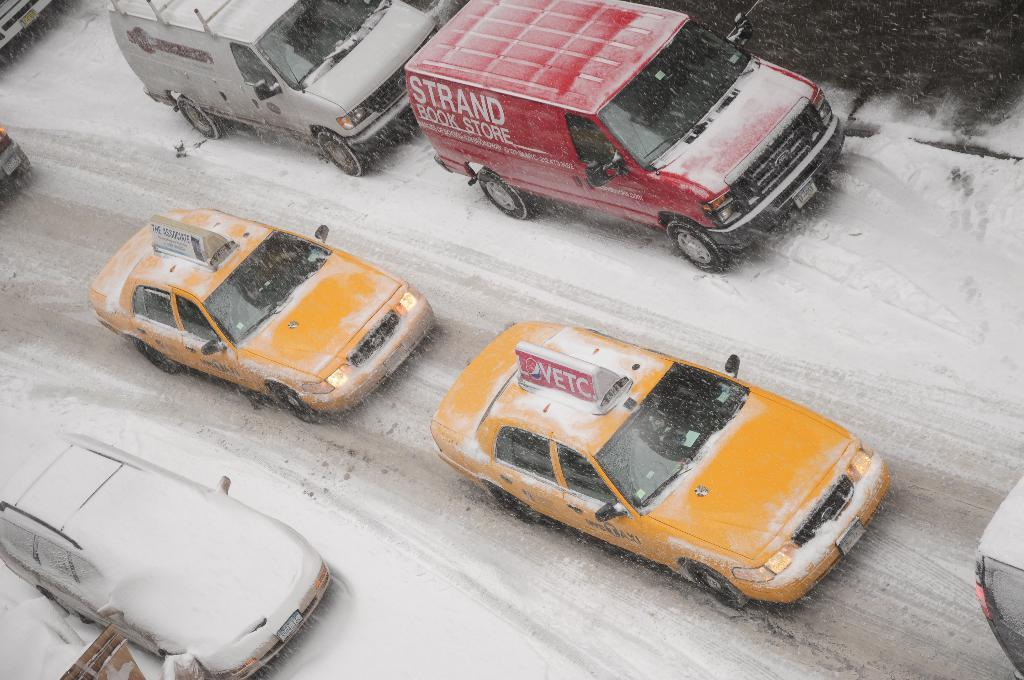<image>
Provide a brief description of the given image. Several vehicles are riding down a snowy street with a taxi cab having a sign for vetc on top of it. 